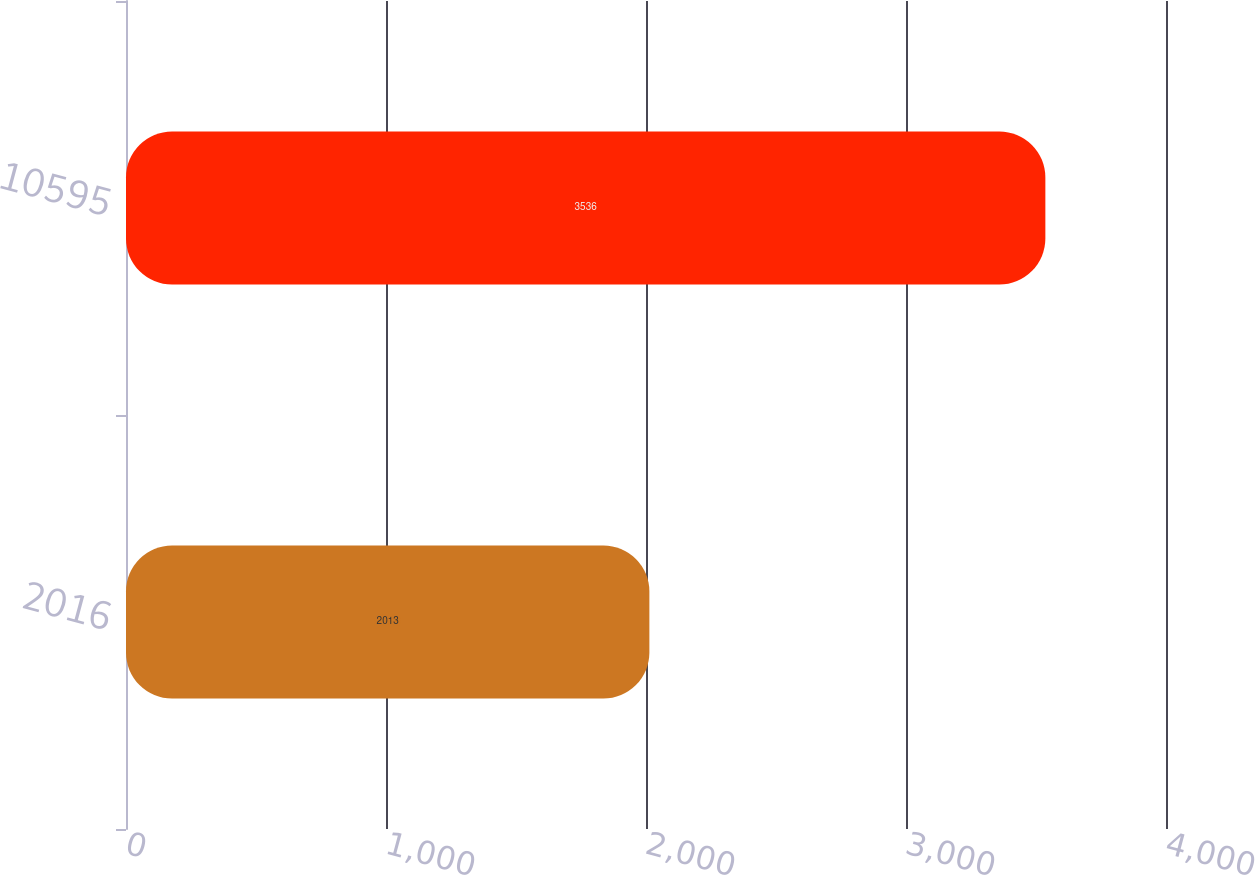Convert chart. <chart><loc_0><loc_0><loc_500><loc_500><bar_chart><fcel>2016<fcel>10595<nl><fcel>2013<fcel>3536<nl></chart> 